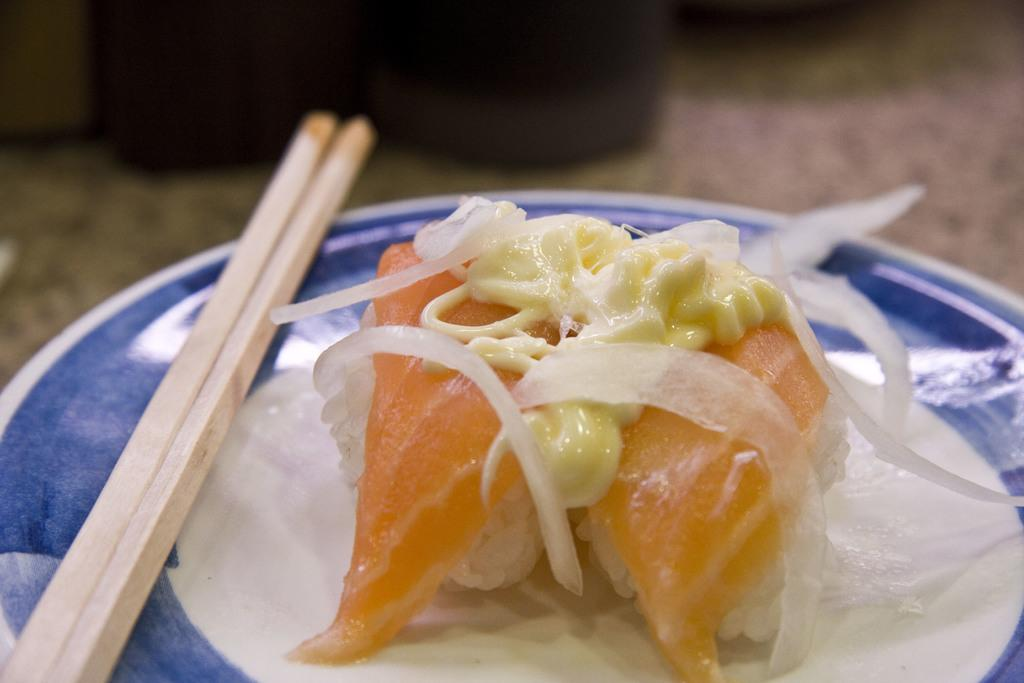What is on the plate that is visible in the image? There is food on a plate in the image. What utensils are present in the image? There are two chopsticks in the image. How much payment is required for the food in the image? There is no information about payment in the image, as it only shows food on a plate and chopsticks. Is there any dirt visible on the plate or chopsticks in the image? There is no dirt visible on the plate or chopsticks in the image. 